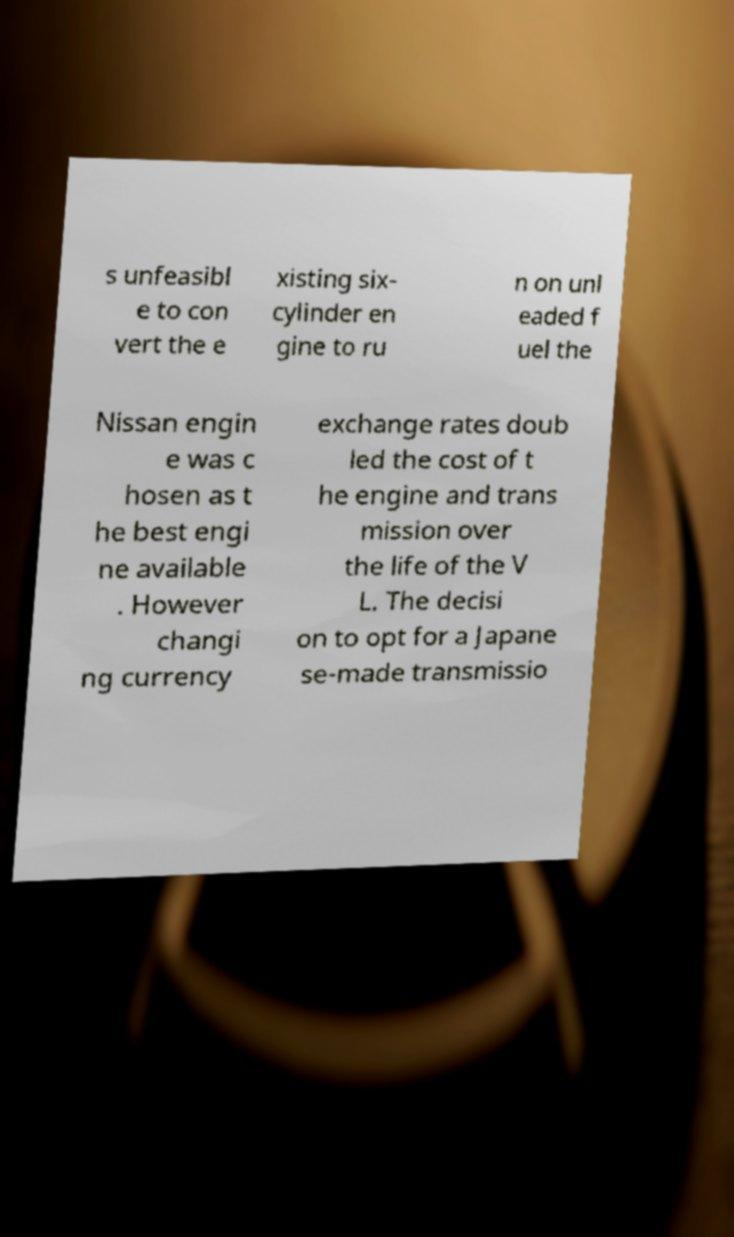I need the written content from this picture converted into text. Can you do that? s unfeasibl e to con vert the e xisting six- cylinder en gine to ru n on unl eaded f uel the Nissan engin e was c hosen as t he best engi ne available . However changi ng currency exchange rates doub led the cost of t he engine and trans mission over the life of the V L. The decisi on to opt for a Japane se-made transmissio 